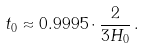Convert formula to latex. <formula><loc_0><loc_0><loc_500><loc_500>t _ { 0 } \approx 0 . 9 9 9 5 \cdot \frac { 2 } { 3 H _ { 0 } } \, .</formula> 